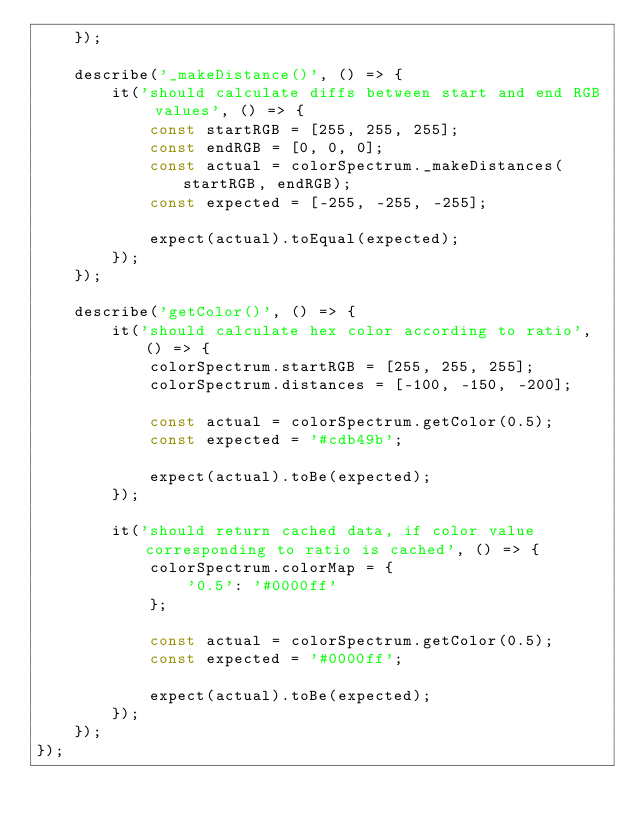<code> <loc_0><loc_0><loc_500><loc_500><_JavaScript_>    });

    describe('_makeDistance()', () => {
        it('should calculate diffs between start and end RGB values', () => {
            const startRGB = [255, 255, 255];
            const endRGB = [0, 0, 0];
            const actual = colorSpectrum._makeDistances(startRGB, endRGB);
            const expected = [-255, -255, -255];

            expect(actual).toEqual(expected);
        });
    });

    describe('getColor()', () => {
        it('should calculate hex color according to ratio', () => {
            colorSpectrum.startRGB = [255, 255, 255];
            colorSpectrum.distances = [-100, -150, -200];

            const actual = colorSpectrum.getColor(0.5);
            const expected = '#cdb49b';

            expect(actual).toBe(expected);
        });

        it('should return cached data, if color value corresponding to ratio is cached', () => {
            colorSpectrum.colorMap = {
                '0.5': '#0000ff'
            };

            const actual = colorSpectrum.getColor(0.5);
            const expected = '#0000ff';

            expect(actual).toBe(expected);
        });
    });
});
</code> 